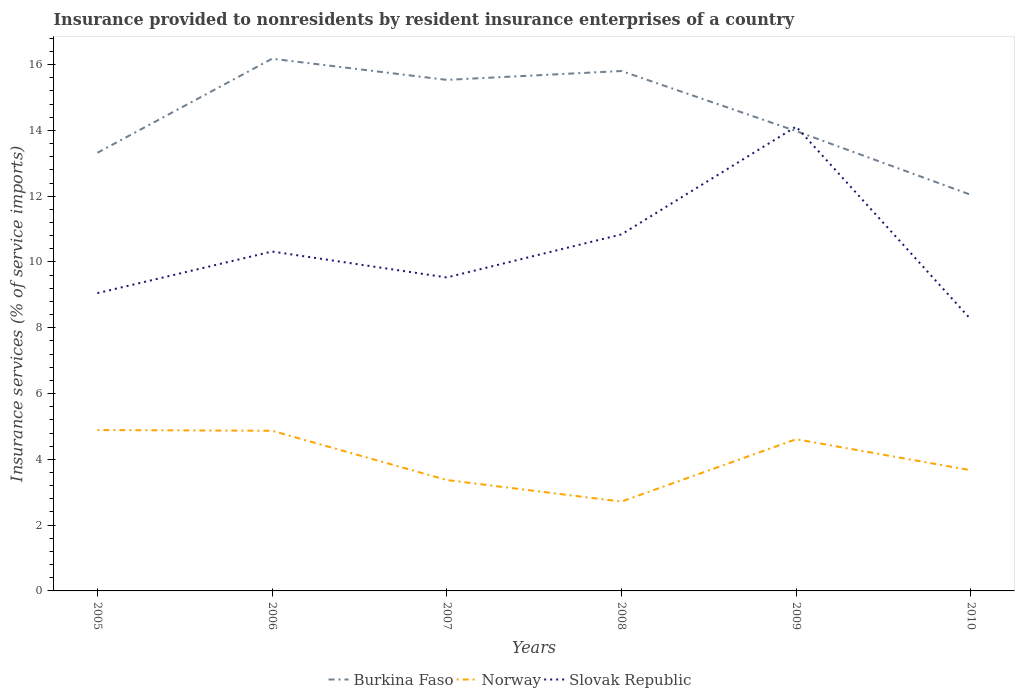Is the number of lines equal to the number of legend labels?
Your response must be concise. Yes. Across all years, what is the maximum insurance provided to nonresidents in Burkina Faso?
Offer a very short reply. 12.04. What is the total insurance provided to nonresidents in Burkina Faso in the graph?
Provide a short and direct response. 1.56. What is the difference between the highest and the second highest insurance provided to nonresidents in Slovak Republic?
Your answer should be very brief. 5.86. What is the difference between the highest and the lowest insurance provided to nonresidents in Burkina Faso?
Offer a very short reply. 3. How many years are there in the graph?
Provide a short and direct response. 6. Does the graph contain grids?
Give a very brief answer. No. How are the legend labels stacked?
Your answer should be compact. Horizontal. What is the title of the graph?
Your answer should be very brief. Insurance provided to nonresidents by resident insurance enterprises of a country. Does "Guam" appear as one of the legend labels in the graph?
Your answer should be very brief. No. What is the label or title of the Y-axis?
Offer a very short reply. Insurance services (% of service imports). What is the Insurance services (% of service imports) in Burkina Faso in 2005?
Give a very brief answer. 13.32. What is the Insurance services (% of service imports) in Norway in 2005?
Provide a short and direct response. 4.89. What is the Insurance services (% of service imports) of Slovak Republic in 2005?
Ensure brevity in your answer.  9.05. What is the Insurance services (% of service imports) in Burkina Faso in 2006?
Give a very brief answer. 16.18. What is the Insurance services (% of service imports) in Norway in 2006?
Provide a succinct answer. 4.87. What is the Insurance services (% of service imports) of Slovak Republic in 2006?
Make the answer very short. 10.32. What is the Insurance services (% of service imports) of Burkina Faso in 2007?
Provide a short and direct response. 15.54. What is the Insurance services (% of service imports) in Norway in 2007?
Provide a succinct answer. 3.37. What is the Insurance services (% of service imports) of Slovak Republic in 2007?
Give a very brief answer. 9.53. What is the Insurance services (% of service imports) of Burkina Faso in 2008?
Offer a very short reply. 15.81. What is the Insurance services (% of service imports) in Norway in 2008?
Offer a terse response. 2.72. What is the Insurance services (% of service imports) in Slovak Republic in 2008?
Your response must be concise. 10.84. What is the Insurance services (% of service imports) in Burkina Faso in 2009?
Provide a short and direct response. 13.98. What is the Insurance services (% of service imports) of Norway in 2009?
Provide a short and direct response. 4.61. What is the Insurance services (% of service imports) in Slovak Republic in 2009?
Ensure brevity in your answer.  14.12. What is the Insurance services (% of service imports) in Burkina Faso in 2010?
Keep it short and to the point. 12.04. What is the Insurance services (% of service imports) in Norway in 2010?
Your answer should be compact. 3.67. What is the Insurance services (% of service imports) of Slovak Republic in 2010?
Offer a terse response. 8.26. Across all years, what is the maximum Insurance services (% of service imports) in Burkina Faso?
Provide a succinct answer. 16.18. Across all years, what is the maximum Insurance services (% of service imports) of Norway?
Ensure brevity in your answer.  4.89. Across all years, what is the maximum Insurance services (% of service imports) in Slovak Republic?
Your answer should be compact. 14.12. Across all years, what is the minimum Insurance services (% of service imports) of Burkina Faso?
Provide a short and direct response. 12.04. Across all years, what is the minimum Insurance services (% of service imports) of Norway?
Give a very brief answer. 2.72. Across all years, what is the minimum Insurance services (% of service imports) in Slovak Republic?
Provide a succinct answer. 8.26. What is the total Insurance services (% of service imports) of Burkina Faso in the graph?
Make the answer very short. 86.87. What is the total Insurance services (% of service imports) of Norway in the graph?
Offer a terse response. 24.13. What is the total Insurance services (% of service imports) in Slovak Republic in the graph?
Offer a terse response. 62.11. What is the difference between the Insurance services (% of service imports) of Burkina Faso in 2005 and that in 2006?
Keep it short and to the point. -2.86. What is the difference between the Insurance services (% of service imports) in Norway in 2005 and that in 2006?
Give a very brief answer. 0.02. What is the difference between the Insurance services (% of service imports) of Slovak Republic in 2005 and that in 2006?
Keep it short and to the point. -1.27. What is the difference between the Insurance services (% of service imports) of Burkina Faso in 2005 and that in 2007?
Make the answer very short. -2.22. What is the difference between the Insurance services (% of service imports) in Norway in 2005 and that in 2007?
Keep it short and to the point. 1.52. What is the difference between the Insurance services (% of service imports) in Slovak Republic in 2005 and that in 2007?
Give a very brief answer. -0.48. What is the difference between the Insurance services (% of service imports) of Burkina Faso in 2005 and that in 2008?
Give a very brief answer. -2.49. What is the difference between the Insurance services (% of service imports) in Norway in 2005 and that in 2008?
Your response must be concise. 2.18. What is the difference between the Insurance services (% of service imports) in Slovak Republic in 2005 and that in 2008?
Your response must be concise. -1.79. What is the difference between the Insurance services (% of service imports) in Burkina Faso in 2005 and that in 2009?
Your answer should be compact. -0.66. What is the difference between the Insurance services (% of service imports) of Norway in 2005 and that in 2009?
Provide a succinct answer. 0.28. What is the difference between the Insurance services (% of service imports) of Slovak Republic in 2005 and that in 2009?
Your answer should be very brief. -5.06. What is the difference between the Insurance services (% of service imports) of Burkina Faso in 2005 and that in 2010?
Keep it short and to the point. 1.28. What is the difference between the Insurance services (% of service imports) of Norway in 2005 and that in 2010?
Offer a terse response. 1.22. What is the difference between the Insurance services (% of service imports) of Slovak Republic in 2005 and that in 2010?
Offer a terse response. 0.8. What is the difference between the Insurance services (% of service imports) of Burkina Faso in 2006 and that in 2007?
Provide a short and direct response. 0.64. What is the difference between the Insurance services (% of service imports) of Norway in 2006 and that in 2007?
Your response must be concise. 1.5. What is the difference between the Insurance services (% of service imports) of Slovak Republic in 2006 and that in 2007?
Your response must be concise. 0.79. What is the difference between the Insurance services (% of service imports) of Burkina Faso in 2006 and that in 2008?
Give a very brief answer. 0.37. What is the difference between the Insurance services (% of service imports) in Norway in 2006 and that in 2008?
Ensure brevity in your answer.  2.15. What is the difference between the Insurance services (% of service imports) of Slovak Republic in 2006 and that in 2008?
Ensure brevity in your answer.  -0.52. What is the difference between the Insurance services (% of service imports) in Burkina Faso in 2006 and that in 2009?
Make the answer very short. 2.2. What is the difference between the Insurance services (% of service imports) in Norway in 2006 and that in 2009?
Provide a short and direct response. 0.26. What is the difference between the Insurance services (% of service imports) of Slovak Republic in 2006 and that in 2009?
Offer a very short reply. -3.8. What is the difference between the Insurance services (% of service imports) of Burkina Faso in 2006 and that in 2010?
Provide a short and direct response. 4.14. What is the difference between the Insurance services (% of service imports) of Norway in 2006 and that in 2010?
Ensure brevity in your answer.  1.2. What is the difference between the Insurance services (% of service imports) in Slovak Republic in 2006 and that in 2010?
Your answer should be very brief. 2.06. What is the difference between the Insurance services (% of service imports) in Burkina Faso in 2007 and that in 2008?
Your answer should be very brief. -0.27. What is the difference between the Insurance services (% of service imports) in Norway in 2007 and that in 2008?
Your answer should be very brief. 0.66. What is the difference between the Insurance services (% of service imports) of Slovak Republic in 2007 and that in 2008?
Make the answer very short. -1.31. What is the difference between the Insurance services (% of service imports) in Burkina Faso in 2007 and that in 2009?
Give a very brief answer. 1.56. What is the difference between the Insurance services (% of service imports) of Norway in 2007 and that in 2009?
Offer a terse response. -1.24. What is the difference between the Insurance services (% of service imports) of Slovak Republic in 2007 and that in 2009?
Provide a short and direct response. -4.59. What is the difference between the Insurance services (% of service imports) in Burkina Faso in 2007 and that in 2010?
Make the answer very short. 3.5. What is the difference between the Insurance services (% of service imports) of Norway in 2007 and that in 2010?
Your answer should be compact. -0.3. What is the difference between the Insurance services (% of service imports) of Slovak Republic in 2007 and that in 2010?
Offer a terse response. 1.27. What is the difference between the Insurance services (% of service imports) of Burkina Faso in 2008 and that in 2009?
Offer a very short reply. 1.83. What is the difference between the Insurance services (% of service imports) in Norway in 2008 and that in 2009?
Make the answer very short. -1.9. What is the difference between the Insurance services (% of service imports) in Slovak Republic in 2008 and that in 2009?
Provide a succinct answer. -3.28. What is the difference between the Insurance services (% of service imports) in Burkina Faso in 2008 and that in 2010?
Ensure brevity in your answer.  3.76. What is the difference between the Insurance services (% of service imports) of Norway in 2008 and that in 2010?
Give a very brief answer. -0.95. What is the difference between the Insurance services (% of service imports) of Slovak Republic in 2008 and that in 2010?
Offer a very short reply. 2.58. What is the difference between the Insurance services (% of service imports) in Burkina Faso in 2009 and that in 2010?
Ensure brevity in your answer.  1.94. What is the difference between the Insurance services (% of service imports) in Norway in 2009 and that in 2010?
Your response must be concise. 0.94. What is the difference between the Insurance services (% of service imports) of Slovak Republic in 2009 and that in 2010?
Your answer should be compact. 5.86. What is the difference between the Insurance services (% of service imports) of Burkina Faso in 2005 and the Insurance services (% of service imports) of Norway in 2006?
Your answer should be very brief. 8.45. What is the difference between the Insurance services (% of service imports) in Burkina Faso in 2005 and the Insurance services (% of service imports) in Slovak Republic in 2006?
Make the answer very short. 3. What is the difference between the Insurance services (% of service imports) of Norway in 2005 and the Insurance services (% of service imports) of Slovak Republic in 2006?
Your response must be concise. -5.43. What is the difference between the Insurance services (% of service imports) in Burkina Faso in 2005 and the Insurance services (% of service imports) in Norway in 2007?
Your answer should be compact. 9.95. What is the difference between the Insurance services (% of service imports) of Burkina Faso in 2005 and the Insurance services (% of service imports) of Slovak Republic in 2007?
Your answer should be very brief. 3.79. What is the difference between the Insurance services (% of service imports) in Norway in 2005 and the Insurance services (% of service imports) in Slovak Republic in 2007?
Your answer should be compact. -4.64. What is the difference between the Insurance services (% of service imports) in Burkina Faso in 2005 and the Insurance services (% of service imports) in Norway in 2008?
Keep it short and to the point. 10.6. What is the difference between the Insurance services (% of service imports) in Burkina Faso in 2005 and the Insurance services (% of service imports) in Slovak Republic in 2008?
Make the answer very short. 2.48. What is the difference between the Insurance services (% of service imports) in Norway in 2005 and the Insurance services (% of service imports) in Slovak Republic in 2008?
Your answer should be very brief. -5.95. What is the difference between the Insurance services (% of service imports) in Burkina Faso in 2005 and the Insurance services (% of service imports) in Norway in 2009?
Your answer should be very brief. 8.71. What is the difference between the Insurance services (% of service imports) in Burkina Faso in 2005 and the Insurance services (% of service imports) in Slovak Republic in 2009?
Your answer should be very brief. -0.8. What is the difference between the Insurance services (% of service imports) in Norway in 2005 and the Insurance services (% of service imports) in Slovak Republic in 2009?
Your answer should be very brief. -9.22. What is the difference between the Insurance services (% of service imports) in Burkina Faso in 2005 and the Insurance services (% of service imports) in Norway in 2010?
Your answer should be very brief. 9.65. What is the difference between the Insurance services (% of service imports) in Burkina Faso in 2005 and the Insurance services (% of service imports) in Slovak Republic in 2010?
Provide a succinct answer. 5.06. What is the difference between the Insurance services (% of service imports) of Norway in 2005 and the Insurance services (% of service imports) of Slovak Republic in 2010?
Your response must be concise. -3.36. What is the difference between the Insurance services (% of service imports) of Burkina Faso in 2006 and the Insurance services (% of service imports) of Norway in 2007?
Offer a very short reply. 12.81. What is the difference between the Insurance services (% of service imports) in Burkina Faso in 2006 and the Insurance services (% of service imports) in Slovak Republic in 2007?
Provide a short and direct response. 6.65. What is the difference between the Insurance services (% of service imports) of Norway in 2006 and the Insurance services (% of service imports) of Slovak Republic in 2007?
Your response must be concise. -4.66. What is the difference between the Insurance services (% of service imports) of Burkina Faso in 2006 and the Insurance services (% of service imports) of Norway in 2008?
Provide a succinct answer. 13.46. What is the difference between the Insurance services (% of service imports) in Burkina Faso in 2006 and the Insurance services (% of service imports) in Slovak Republic in 2008?
Your response must be concise. 5.34. What is the difference between the Insurance services (% of service imports) of Norway in 2006 and the Insurance services (% of service imports) of Slovak Republic in 2008?
Your answer should be very brief. -5.97. What is the difference between the Insurance services (% of service imports) of Burkina Faso in 2006 and the Insurance services (% of service imports) of Norway in 2009?
Ensure brevity in your answer.  11.57. What is the difference between the Insurance services (% of service imports) in Burkina Faso in 2006 and the Insurance services (% of service imports) in Slovak Republic in 2009?
Offer a very short reply. 2.06. What is the difference between the Insurance services (% of service imports) in Norway in 2006 and the Insurance services (% of service imports) in Slovak Republic in 2009?
Give a very brief answer. -9.25. What is the difference between the Insurance services (% of service imports) in Burkina Faso in 2006 and the Insurance services (% of service imports) in Norway in 2010?
Provide a short and direct response. 12.51. What is the difference between the Insurance services (% of service imports) in Burkina Faso in 2006 and the Insurance services (% of service imports) in Slovak Republic in 2010?
Keep it short and to the point. 7.92. What is the difference between the Insurance services (% of service imports) of Norway in 2006 and the Insurance services (% of service imports) of Slovak Republic in 2010?
Your answer should be compact. -3.39. What is the difference between the Insurance services (% of service imports) of Burkina Faso in 2007 and the Insurance services (% of service imports) of Norway in 2008?
Make the answer very short. 12.82. What is the difference between the Insurance services (% of service imports) in Burkina Faso in 2007 and the Insurance services (% of service imports) in Slovak Republic in 2008?
Give a very brief answer. 4.7. What is the difference between the Insurance services (% of service imports) in Norway in 2007 and the Insurance services (% of service imports) in Slovak Republic in 2008?
Ensure brevity in your answer.  -7.47. What is the difference between the Insurance services (% of service imports) in Burkina Faso in 2007 and the Insurance services (% of service imports) in Norway in 2009?
Keep it short and to the point. 10.93. What is the difference between the Insurance services (% of service imports) in Burkina Faso in 2007 and the Insurance services (% of service imports) in Slovak Republic in 2009?
Ensure brevity in your answer.  1.42. What is the difference between the Insurance services (% of service imports) of Norway in 2007 and the Insurance services (% of service imports) of Slovak Republic in 2009?
Provide a short and direct response. -10.75. What is the difference between the Insurance services (% of service imports) in Burkina Faso in 2007 and the Insurance services (% of service imports) in Norway in 2010?
Offer a terse response. 11.87. What is the difference between the Insurance services (% of service imports) in Burkina Faso in 2007 and the Insurance services (% of service imports) in Slovak Republic in 2010?
Give a very brief answer. 7.28. What is the difference between the Insurance services (% of service imports) in Norway in 2007 and the Insurance services (% of service imports) in Slovak Republic in 2010?
Your answer should be very brief. -4.88. What is the difference between the Insurance services (% of service imports) of Burkina Faso in 2008 and the Insurance services (% of service imports) of Norway in 2009?
Give a very brief answer. 11.19. What is the difference between the Insurance services (% of service imports) of Burkina Faso in 2008 and the Insurance services (% of service imports) of Slovak Republic in 2009?
Your answer should be very brief. 1.69. What is the difference between the Insurance services (% of service imports) of Norway in 2008 and the Insurance services (% of service imports) of Slovak Republic in 2009?
Provide a succinct answer. -11.4. What is the difference between the Insurance services (% of service imports) in Burkina Faso in 2008 and the Insurance services (% of service imports) in Norway in 2010?
Give a very brief answer. 12.14. What is the difference between the Insurance services (% of service imports) of Burkina Faso in 2008 and the Insurance services (% of service imports) of Slovak Republic in 2010?
Provide a short and direct response. 7.55. What is the difference between the Insurance services (% of service imports) in Norway in 2008 and the Insurance services (% of service imports) in Slovak Republic in 2010?
Provide a short and direct response. -5.54. What is the difference between the Insurance services (% of service imports) of Burkina Faso in 2009 and the Insurance services (% of service imports) of Norway in 2010?
Make the answer very short. 10.31. What is the difference between the Insurance services (% of service imports) of Burkina Faso in 2009 and the Insurance services (% of service imports) of Slovak Republic in 2010?
Your answer should be compact. 5.73. What is the difference between the Insurance services (% of service imports) of Norway in 2009 and the Insurance services (% of service imports) of Slovak Republic in 2010?
Make the answer very short. -3.64. What is the average Insurance services (% of service imports) in Burkina Faso per year?
Your answer should be very brief. 14.48. What is the average Insurance services (% of service imports) in Norway per year?
Provide a short and direct response. 4.02. What is the average Insurance services (% of service imports) in Slovak Republic per year?
Ensure brevity in your answer.  10.35. In the year 2005, what is the difference between the Insurance services (% of service imports) of Burkina Faso and Insurance services (% of service imports) of Norway?
Provide a succinct answer. 8.43. In the year 2005, what is the difference between the Insurance services (% of service imports) of Burkina Faso and Insurance services (% of service imports) of Slovak Republic?
Offer a very short reply. 4.27. In the year 2005, what is the difference between the Insurance services (% of service imports) in Norway and Insurance services (% of service imports) in Slovak Republic?
Provide a short and direct response. -4.16. In the year 2006, what is the difference between the Insurance services (% of service imports) in Burkina Faso and Insurance services (% of service imports) in Norway?
Your answer should be very brief. 11.31. In the year 2006, what is the difference between the Insurance services (% of service imports) in Burkina Faso and Insurance services (% of service imports) in Slovak Republic?
Offer a very short reply. 5.86. In the year 2006, what is the difference between the Insurance services (% of service imports) in Norway and Insurance services (% of service imports) in Slovak Republic?
Your response must be concise. -5.45. In the year 2007, what is the difference between the Insurance services (% of service imports) of Burkina Faso and Insurance services (% of service imports) of Norway?
Ensure brevity in your answer.  12.17. In the year 2007, what is the difference between the Insurance services (% of service imports) of Burkina Faso and Insurance services (% of service imports) of Slovak Republic?
Give a very brief answer. 6.01. In the year 2007, what is the difference between the Insurance services (% of service imports) of Norway and Insurance services (% of service imports) of Slovak Republic?
Offer a very short reply. -6.16. In the year 2008, what is the difference between the Insurance services (% of service imports) in Burkina Faso and Insurance services (% of service imports) in Norway?
Offer a terse response. 13.09. In the year 2008, what is the difference between the Insurance services (% of service imports) in Burkina Faso and Insurance services (% of service imports) in Slovak Republic?
Give a very brief answer. 4.97. In the year 2008, what is the difference between the Insurance services (% of service imports) of Norway and Insurance services (% of service imports) of Slovak Republic?
Ensure brevity in your answer.  -8.12. In the year 2009, what is the difference between the Insurance services (% of service imports) in Burkina Faso and Insurance services (% of service imports) in Norway?
Give a very brief answer. 9.37. In the year 2009, what is the difference between the Insurance services (% of service imports) in Burkina Faso and Insurance services (% of service imports) in Slovak Republic?
Your response must be concise. -0.14. In the year 2009, what is the difference between the Insurance services (% of service imports) in Norway and Insurance services (% of service imports) in Slovak Republic?
Keep it short and to the point. -9.5. In the year 2010, what is the difference between the Insurance services (% of service imports) of Burkina Faso and Insurance services (% of service imports) of Norway?
Make the answer very short. 8.37. In the year 2010, what is the difference between the Insurance services (% of service imports) of Burkina Faso and Insurance services (% of service imports) of Slovak Republic?
Give a very brief answer. 3.79. In the year 2010, what is the difference between the Insurance services (% of service imports) in Norway and Insurance services (% of service imports) in Slovak Republic?
Provide a short and direct response. -4.59. What is the ratio of the Insurance services (% of service imports) of Burkina Faso in 2005 to that in 2006?
Offer a very short reply. 0.82. What is the ratio of the Insurance services (% of service imports) of Norway in 2005 to that in 2006?
Your response must be concise. 1. What is the ratio of the Insurance services (% of service imports) of Slovak Republic in 2005 to that in 2006?
Your answer should be very brief. 0.88. What is the ratio of the Insurance services (% of service imports) of Burkina Faso in 2005 to that in 2007?
Your response must be concise. 0.86. What is the ratio of the Insurance services (% of service imports) of Norway in 2005 to that in 2007?
Provide a succinct answer. 1.45. What is the ratio of the Insurance services (% of service imports) of Slovak Republic in 2005 to that in 2007?
Make the answer very short. 0.95. What is the ratio of the Insurance services (% of service imports) of Burkina Faso in 2005 to that in 2008?
Give a very brief answer. 0.84. What is the ratio of the Insurance services (% of service imports) in Norway in 2005 to that in 2008?
Offer a very short reply. 1.8. What is the ratio of the Insurance services (% of service imports) of Slovak Republic in 2005 to that in 2008?
Keep it short and to the point. 0.84. What is the ratio of the Insurance services (% of service imports) in Burkina Faso in 2005 to that in 2009?
Ensure brevity in your answer.  0.95. What is the ratio of the Insurance services (% of service imports) in Norway in 2005 to that in 2009?
Keep it short and to the point. 1.06. What is the ratio of the Insurance services (% of service imports) of Slovak Republic in 2005 to that in 2009?
Offer a terse response. 0.64. What is the ratio of the Insurance services (% of service imports) of Burkina Faso in 2005 to that in 2010?
Offer a very short reply. 1.11. What is the ratio of the Insurance services (% of service imports) of Norway in 2005 to that in 2010?
Give a very brief answer. 1.33. What is the ratio of the Insurance services (% of service imports) of Slovak Republic in 2005 to that in 2010?
Provide a short and direct response. 1.1. What is the ratio of the Insurance services (% of service imports) of Burkina Faso in 2006 to that in 2007?
Make the answer very short. 1.04. What is the ratio of the Insurance services (% of service imports) of Norway in 2006 to that in 2007?
Your response must be concise. 1.44. What is the ratio of the Insurance services (% of service imports) of Slovak Republic in 2006 to that in 2007?
Keep it short and to the point. 1.08. What is the ratio of the Insurance services (% of service imports) of Burkina Faso in 2006 to that in 2008?
Keep it short and to the point. 1.02. What is the ratio of the Insurance services (% of service imports) of Norway in 2006 to that in 2008?
Offer a terse response. 1.79. What is the ratio of the Insurance services (% of service imports) in Burkina Faso in 2006 to that in 2009?
Provide a succinct answer. 1.16. What is the ratio of the Insurance services (% of service imports) in Norway in 2006 to that in 2009?
Provide a succinct answer. 1.06. What is the ratio of the Insurance services (% of service imports) in Slovak Republic in 2006 to that in 2009?
Provide a succinct answer. 0.73. What is the ratio of the Insurance services (% of service imports) of Burkina Faso in 2006 to that in 2010?
Provide a succinct answer. 1.34. What is the ratio of the Insurance services (% of service imports) in Norway in 2006 to that in 2010?
Ensure brevity in your answer.  1.33. What is the ratio of the Insurance services (% of service imports) of Slovak Republic in 2006 to that in 2010?
Your response must be concise. 1.25. What is the ratio of the Insurance services (% of service imports) in Norway in 2007 to that in 2008?
Provide a succinct answer. 1.24. What is the ratio of the Insurance services (% of service imports) in Slovak Republic in 2007 to that in 2008?
Your answer should be very brief. 0.88. What is the ratio of the Insurance services (% of service imports) of Burkina Faso in 2007 to that in 2009?
Offer a very short reply. 1.11. What is the ratio of the Insurance services (% of service imports) of Norway in 2007 to that in 2009?
Provide a succinct answer. 0.73. What is the ratio of the Insurance services (% of service imports) in Slovak Republic in 2007 to that in 2009?
Keep it short and to the point. 0.68. What is the ratio of the Insurance services (% of service imports) of Burkina Faso in 2007 to that in 2010?
Your answer should be very brief. 1.29. What is the ratio of the Insurance services (% of service imports) of Norway in 2007 to that in 2010?
Your response must be concise. 0.92. What is the ratio of the Insurance services (% of service imports) of Slovak Republic in 2007 to that in 2010?
Provide a succinct answer. 1.15. What is the ratio of the Insurance services (% of service imports) in Burkina Faso in 2008 to that in 2009?
Give a very brief answer. 1.13. What is the ratio of the Insurance services (% of service imports) in Norway in 2008 to that in 2009?
Provide a succinct answer. 0.59. What is the ratio of the Insurance services (% of service imports) in Slovak Republic in 2008 to that in 2009?
Make the answer very short. 0.77. What is the ratio of the Insurance services (% of service imports) of Burkina Faso in 2008 to that in 2010?
Keep it short and to the point. 1.31. What is the ratio of the Insurance services (% of service imports) in Norway in 2008 to that in 2010?
Offer a very short reply. 0.74. What is the ratio of the Insurance services (% of service imports) of Slovak Republic in 2008 to that in 2010?
Give a very brief answer. 1.31. What is the ratio of the Insurance services (% of service imports) in Burkina Faso in 2009 to that in 2010?
Your answer should be very brief. 1.16. What is the ratio of the Insurance services (% of service imports) in Norway in 2009 to that in 2010?
Give a very brief answer. 1.26. What is the ratio of the Insurance services (% of service imports) of Slovak Republic in 2009 to that in 2010?
Your answer should be very brief. 1.71. What is the difference between the highest and the second highest Insurance services (% of service imports) in Burkina Faso?
Your response must be concise. 0.37. What is the difference between the highest and the second highest Insurance services (% of service imports) of Norway?
Provide a short and direct response. 0.02. What is the difference between the highest and the second highest Insurance services (% of service imports) of Slovak Republic?
Your response must be concise. 3.28. What is the difference between the highest and the lowest Insurance services (% of service imports) of Burkina Faso?
Ensure brevity in your answer.  4.14. What is the difference between the highest and the lowest Insurance services (% of service imports) of Norway?
Ensure brevity in your answer.  2.18. What is the difference between the highest and the lowest Insurance services (% of service imports) in Slovak Republic?
Your answer should be very brief. 5.86. 